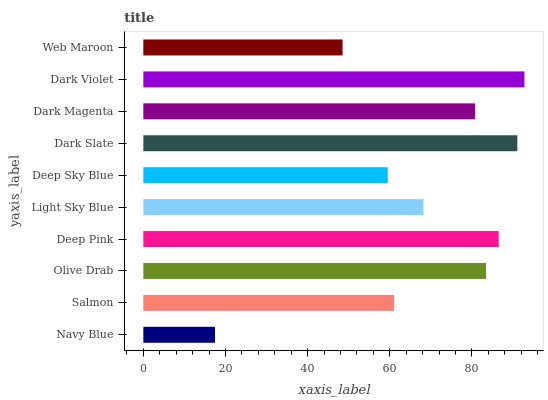Is Navy Blue the minimum?
Answer yes or no. Yes. Is Dark Violet the maximum?
Answer yes or no. Yes. Is Salmon the minimum?
Answer yes or no. No. Is Salmon the maximum?
Answer yes or no. No. Is Salmon greater than Navy Blue?
Answer yes or no. Yes. Is Navy Blue less than Salmon?
Answer yes or no. Yes. Is Navy Blue greater than Salmon?
Answer yes or no. No. Is Salmon less than Navy Blue?
Answer yes or no. No. Is Dark Magenta the high median?
Answer yes or no. Yes. Is Light Sky Blue the low median?
Answer yes or no. Yes. Is Light Sky Blue the high median?
Answer yes or no. No. Is Dark Violet the low median?
Answer yes or no. No. 